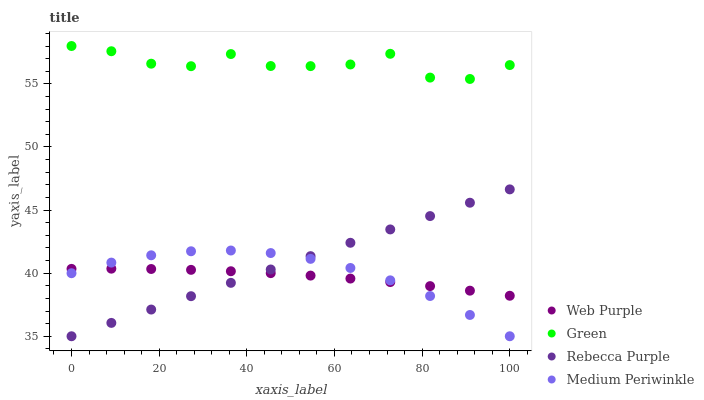Does Web Purple have the minimum area under the curve?
Answer yes or no. Yes. Does Green have the maximum area under the curve?
Answer yes or no. Yes. Does Green have the minimum area under the curve?
Answer yes or no. No. Does Web Purple have the maximum area under the curve?
Answer yes or no. No. Is Rebecca Purple the smoothest?
Answer yes or no. Yes. Is Green the roughest?
Answer yes or no. Yes. Is Web Purple the smoothest?
Answer yes or no. No. Is Web Purple the roughest?
Answer yes or no. No. Does Medium Periwinkle have the lowest value?
Answer yes or no. Yes. Does Web Purple have the lowest value?
Answer yes or no. No. Does Green have the highest value?
Answer yes or no. Yes. Does Web Purple have the highest value?
Answer yes or no. No. Is Medium Periwinkle less than Green?
Answer yes or no. Yes. Is Green greater than Rebecca Purple?
Answer yes or no. Yes. Does Web Purple intersect Rebecca Purple?
Answer yes or no. Yes. Is Web Purple less than Rebecca Purple?
Answer yes or no. No. Is Web Purple greater than Rebecca Purple?
Answer yes or no. No. Does Medium Periwinkle intersect Green?
Answer yes or no. No. 